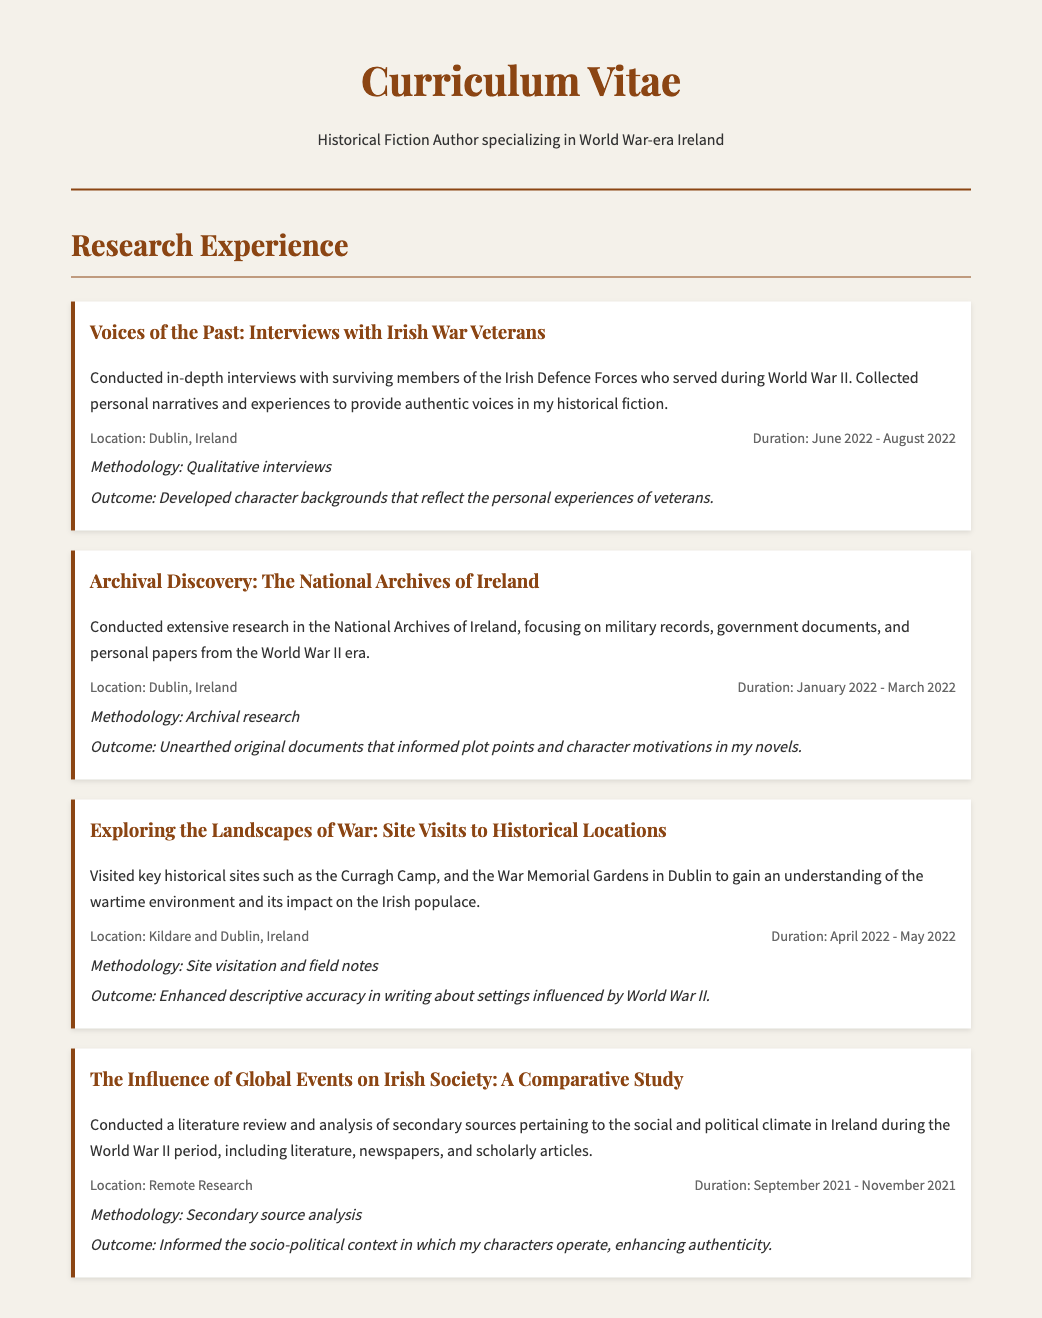What was the duration of the project "Voices of the Past"? The project "Voices of the Past" took place from June 2022 to August 2022, as stated in the project details.
Answer: June 2022 - August 2022 Where did the archival research take place? The archival research was conducted at the National Archives of Ireland, as detailed in the document.
Answer: National Archives of Ireland What methodology was used in the "Exploring the Landscapes of War" project? The methodology mentioned for this project is site visitation and field notes, indicated under the project's details.
Answer: Site visitation and field notes What was one outcome of the "Archival Discovery" project? The outcome mentioned for the "Archival Discovery" project was the unearthing of original documents that informed plot points and character motivations in the novels.
Answer: Informed plot points and character motivations What type of research was conducted for "The Influence of Global Events on Irish Society"? The project involved secondary source analysis, as mentioned in the methodology section of the project.
Answer: Secondary source analysis How long did the "Exploring the Landscapes of War" project last? The duration of the project was from April 2022 to May 2022, as stated in the project details.
Answer: April 2022 - May 2022 What city was central to the interviews conducted? The interviews were conducted in Dublin, Ireland, as indicated in the project location.
Answer: Dublin, Ireland What was the main focus of the "The Influence of Global Events on Irish Society" project? The main focus was on the social and political climate in Ireland during the World War II period, as described in the project description.
Answer: Social and political climate during World War II 